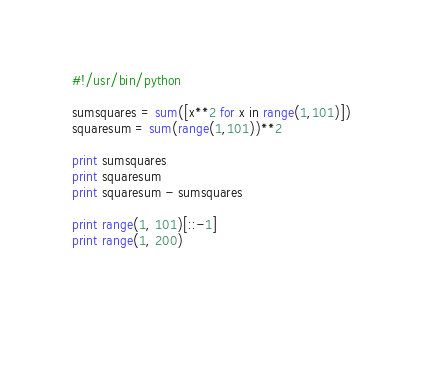<code> <loc_0><loc_0><loc_500><loc_500><_Python_>#!/usr/bin/python
	
sumsquares = sum([x**2 for x in range(1,101)])
squaresum = sum(range(1,101))**2

print sumsquares
print squaresum
print squaresum - sumsquares

print range(1, 101)[::-1]
print range(1, 200)

		
	</code> 